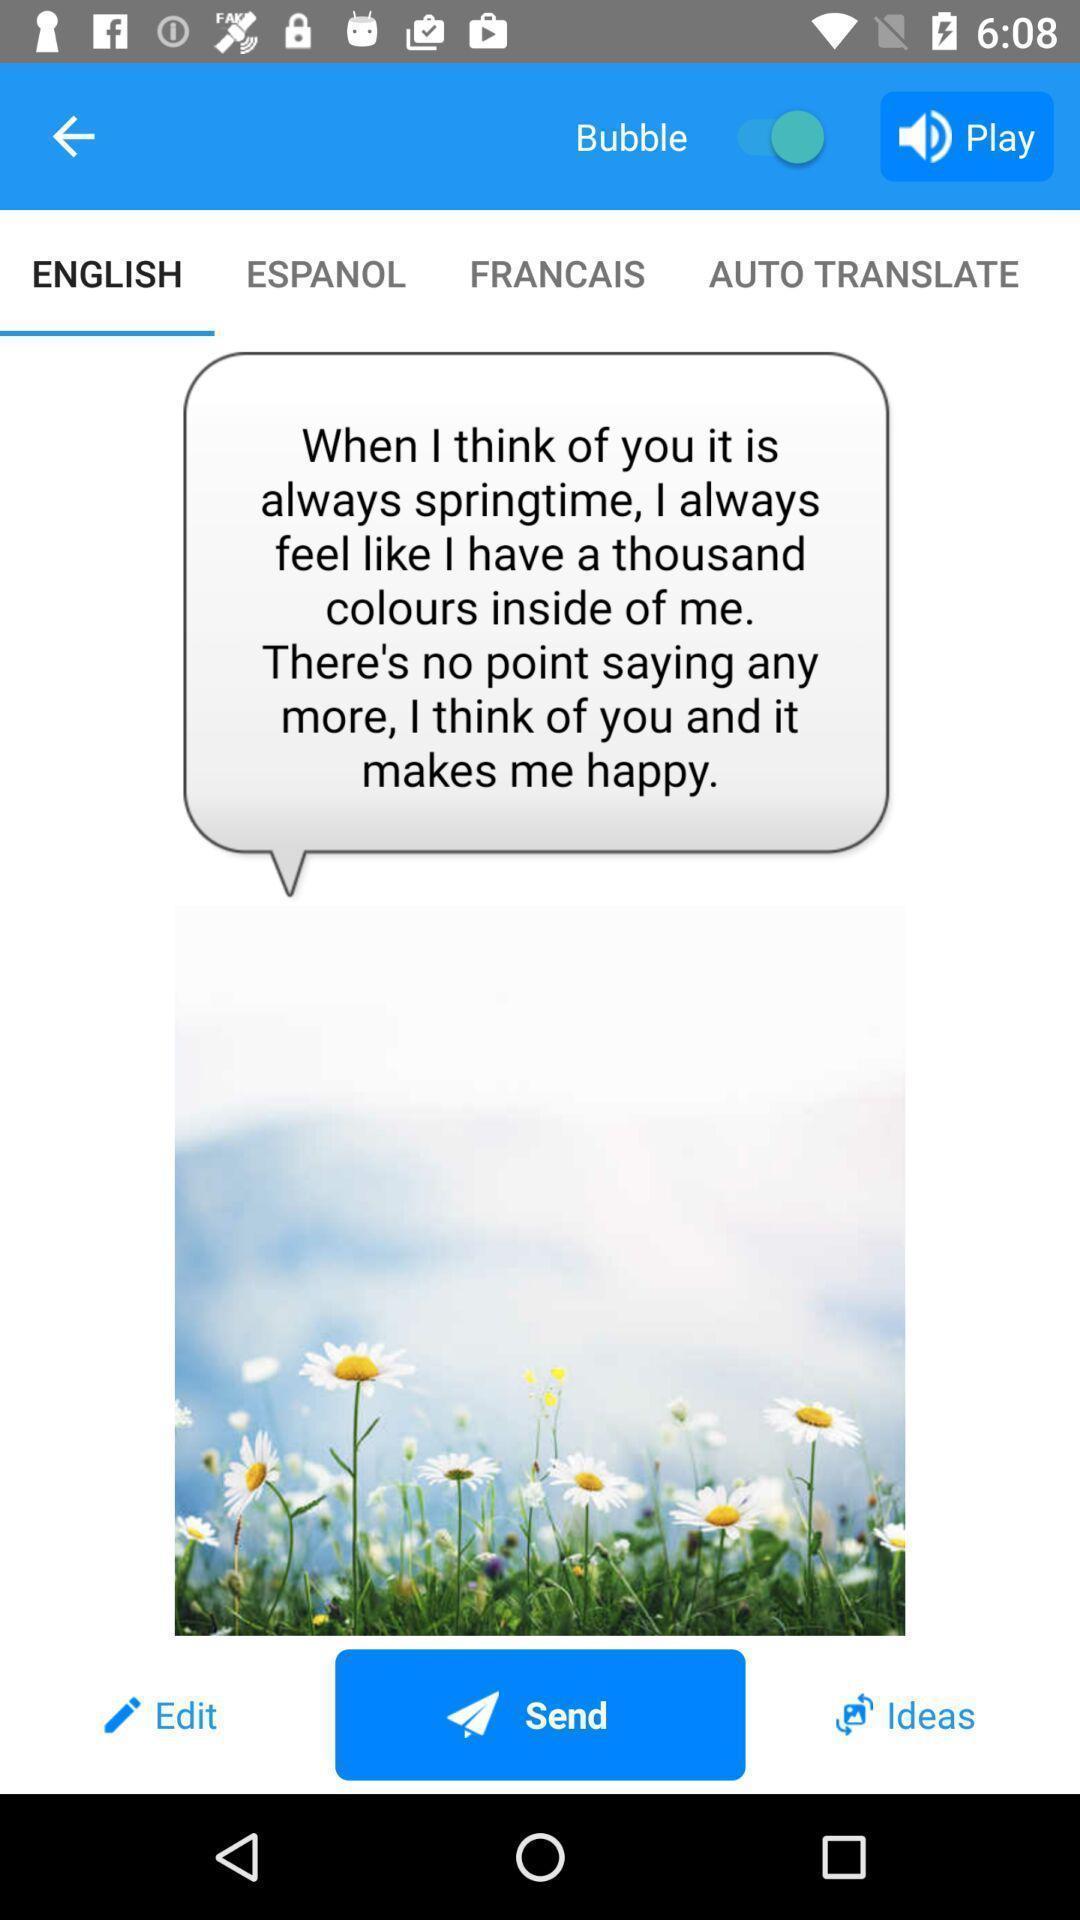Describe this image in words. Page displaying information about stickers and emoji application. 